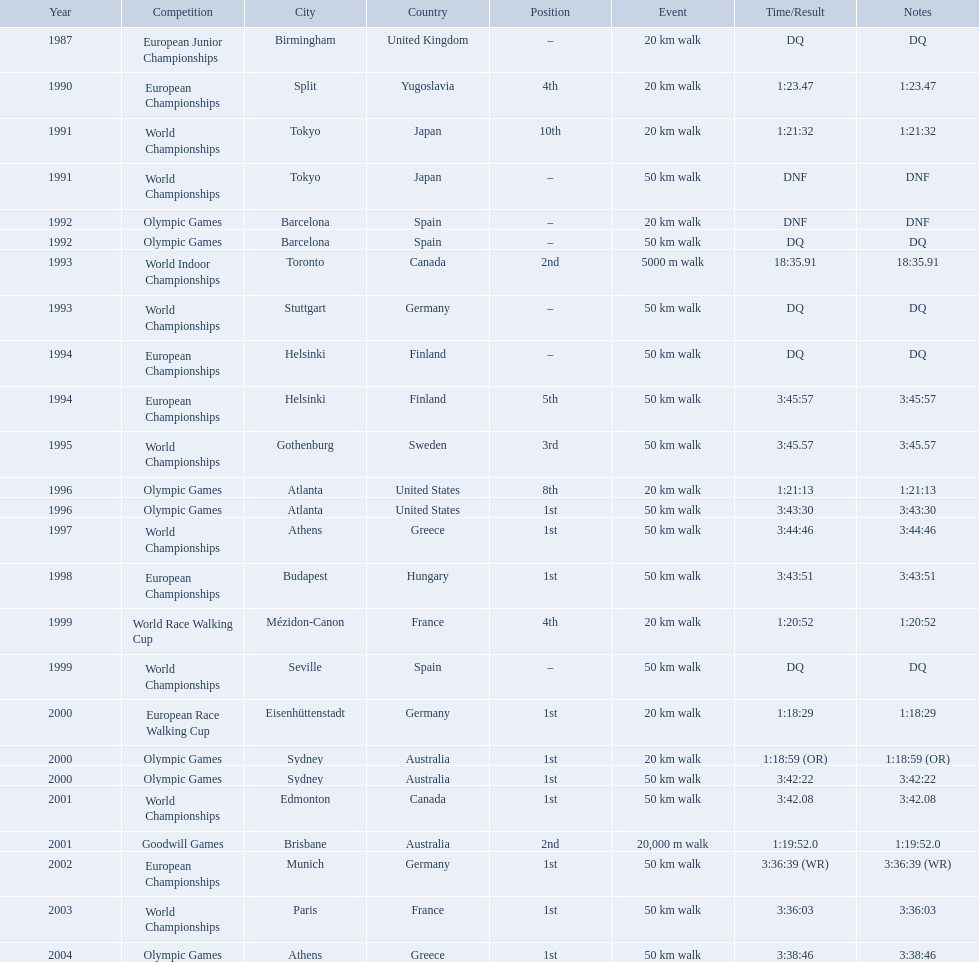Which of the competitions were 50 km walks? World Championships, Olympic Games, World Championships, European Championships, European Championships, World Championships, Olympic Games, World Championships, European Championships, World Championships, Olympic Games, World Championships, European Championships, World Championships, Olympic Games. Of these, which took place during or after the year 2000? Olympic Games, World Championships, European Championships, World Championships, Olympic Games. From these, which took place in athens, greece? Olympic Games. What was the time to finish for this competition? 3:38:46. What are the notes DQ, 1:23.47, 1:21:32, DNF, DNF, DQ, 18:35.91, DQ, DQ, 3:45:57, 3:45.57, 1:21:13, 3:43:30, 3:44:46, 3:43:51, 1:20:52, DQ, 1:18:29, 1:18:59 (OR), 3:42:22, 3:42.08, 1:19:52.0, 3:36:39 (WR), 3:36:03, 3:38:46. What time does the notes for 2004 show 3:38:46. 